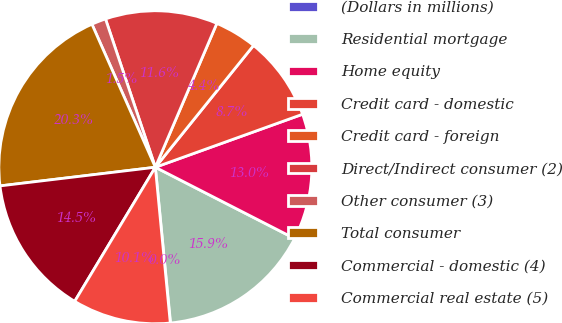Convert chart to OTSL. <chart><loc_0><loc_0><loc_500><loc_500><pie_chart><fcel>(Dollars in millions)<fcel>Residential mortgage<fcel>Home equity<fcel>Credit card - domestic<fcel>Credit card - foreign<fcel>Direct/Indirect consumer (2)<fcel>Other consumer (3)<fcel>Total consumer<fcel>Commercial - domestic (4)<fcel>Commercial real estate (5)<nl><fcel>0.03%<fcel>15.92%<fcel>13.03%<fcel>8.7%<fcel>4.37%<fcel>11.59%<fcel>1.48%<fcel>20.26%<fcel>14.48%<fcel>10.14%<nl></chart> 